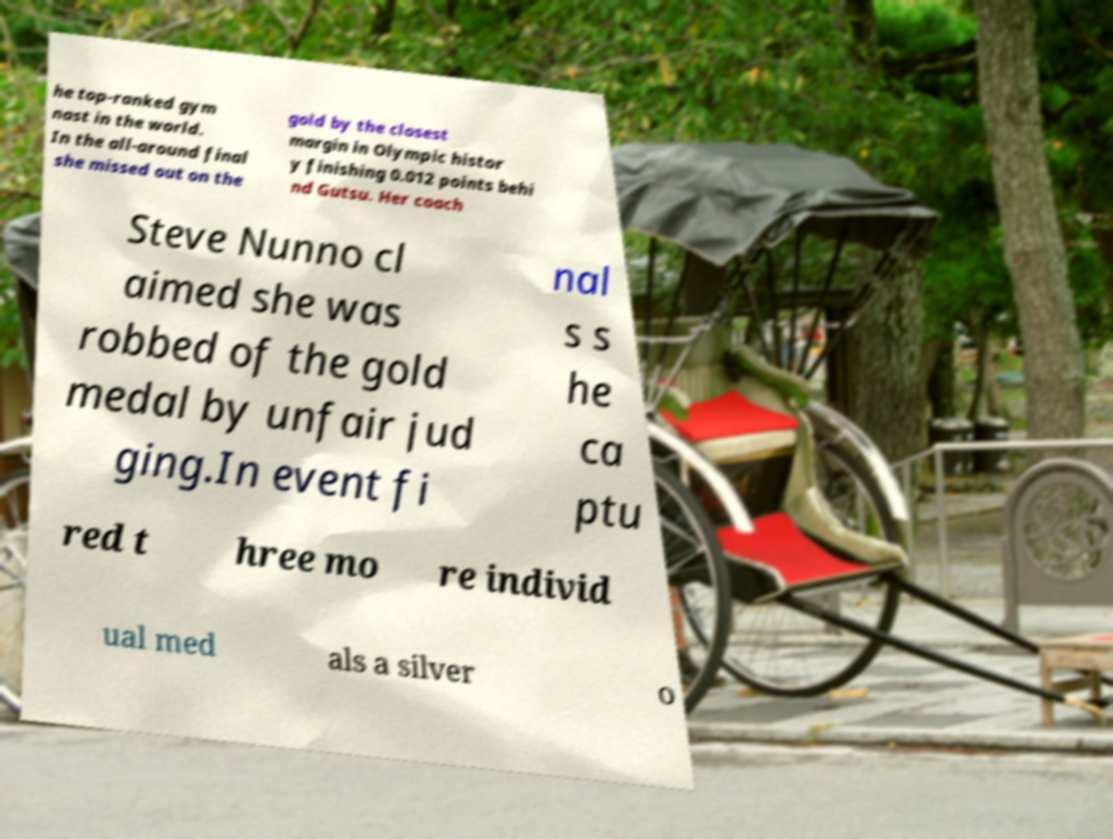There's text embedded in this image that I need extracted. Can you transcribe it verbatim? he top-ranked gym nast in the world. In the all-around final she missed out on the gold by the closest margin in Olympic histor y finishing 0.012 points behi nd Gutsu. Her coach Steve Nunno cl aimed she was robbed of the gold medal by unfair jud ging.In event fi nal s s he ca ptu red t hree mo re individ ual med als a silver o 